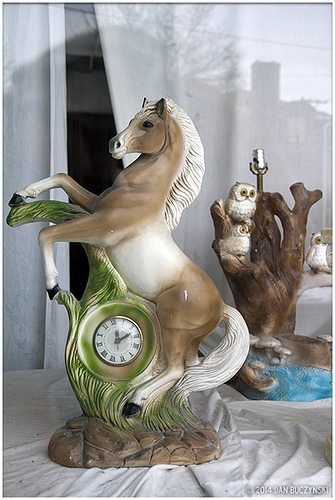<image>
Can you confirm if the clock is above the table? Yes. The clock is positioned above the table in the vertical space, higher up in the scene. Where is the clock in relation to the curtain? Is it to the left of the curtain? No. The clock is not to the left of the curtain. From this viewpoint, they have a different horizontal relationship. 